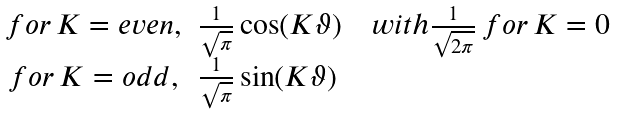<formula> <loc_0><loc_0><loc_500><loc_500>\begin{array} { c l } f o r \, K = e v e n , & \frac { 1 } { \sqrt { \pi } } \cos ( K \vartheta ) \quad w i t h \frac { 1 } { \sqrt { 2 \pi } } \, f o r \, K = 0 \\ f o r \, K = o d d , & \frac { 1 } { \sqrt { \pi } } \sin ( K \vartheta ) \end{array}</formula> 